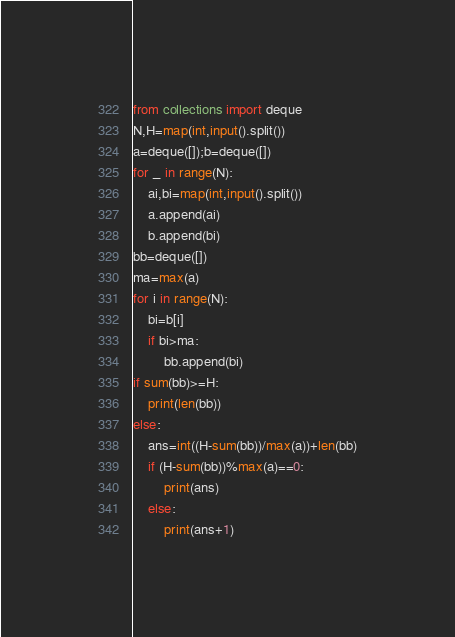<code> <loc_0><loc_0><loc_500><loc_500><_Python_>from collections import deque
N,H=map(int,input().split())
a=deque([]);b=deque([])
for _ in range(N):
    ai,bi=map(int,input().split())
    a.append(ai)
    b.append(bi)
bb=deque([])
ma=max(a)
for i in range(N):
    bi=b[i]
    if bi>ma:
        bb.append(bi)
if sum(bb)>=H:
    print(len(bb))
else:
    ans=int((H-sum(bb))/max(a))+len(bb)
    if (H-sum(bb))%max(a)==0:
        print(ans)
    else:
        print(ans+1)</code> 